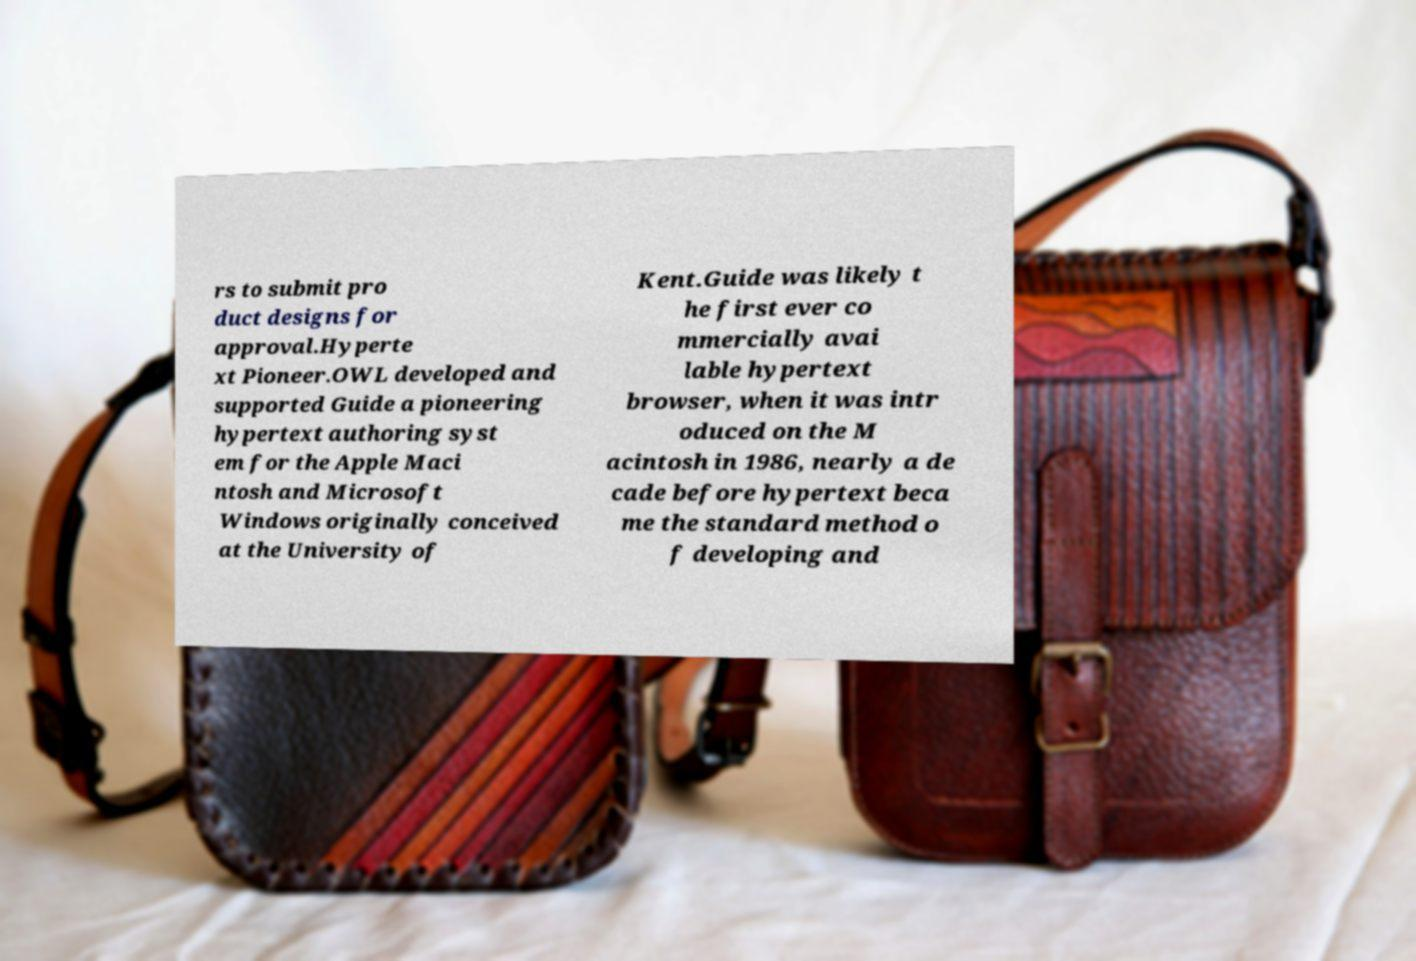Could you extract and type out the text from this image? rs to submit pro duct designs for approval.Hyperte xt Pioneer.OWL developed and supported Guide a pioneering hypertext authoring syst em for the Apple Maci ntosh and Microsoft Windows originally conceived at the University of Kent.Guide was likely t he first ever co mmercially avai lable hypertext browser, when it was intr oduced on the M acintosh in 1986, nearly a de cade before hypertext beca me the standard method o f developing and 